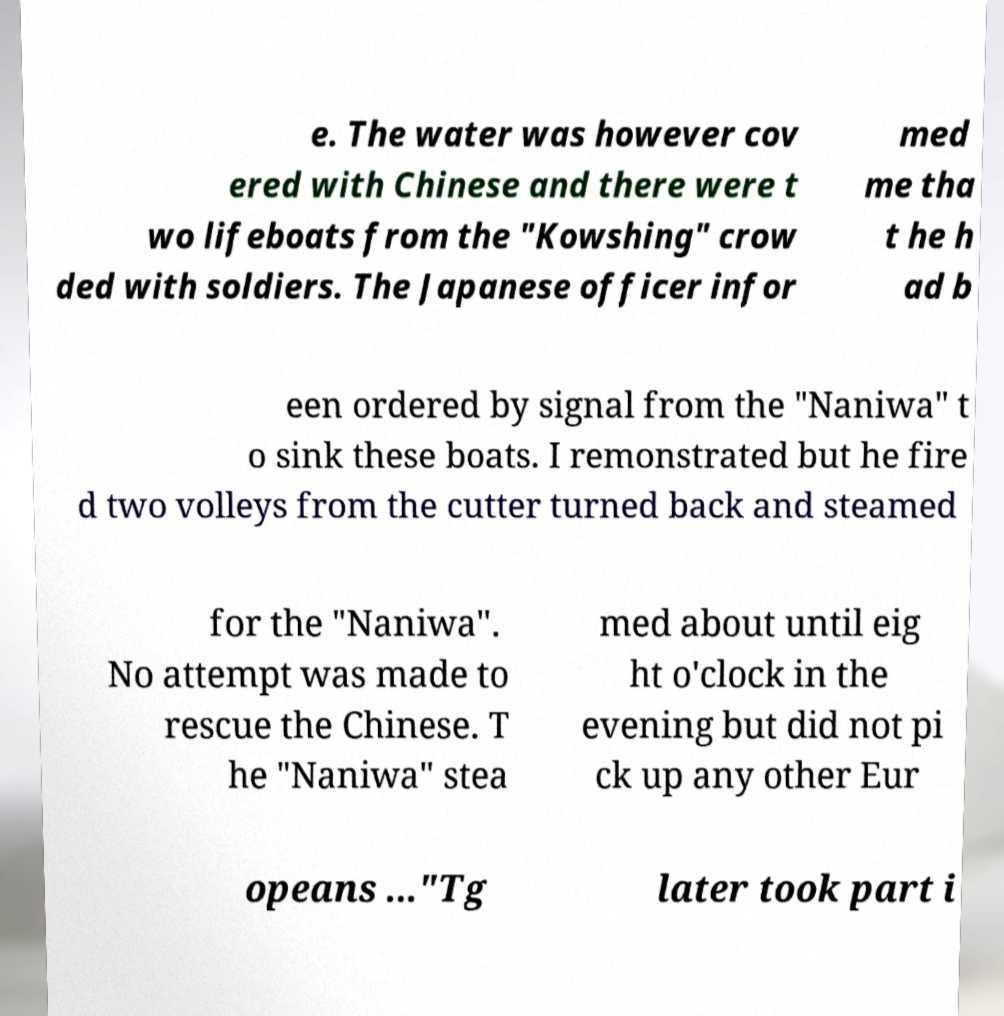Could you extract and type out the text from this image? e. The water was however cov ered with Chinese and there were t wo lifeboats from the "Kowshing" crow ded with soldiers. The Japanese officer infor med me tha t he h ad b een ordered by signal from the "Naniwa" t o sink these boats. I remonstrated but he fire d two volleys from the cutter turned back and steamed for the "Naniwa". No attempt was made to rescue the Chinese. T he "Naniwa" stea med about until eig ht o'clock in the evening but did not pi ck up any other Eur opeans ..."Tg later took part i 